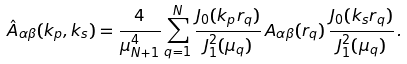<formula> <loc_0><loc_0><loc_500><loc_500>\hat { A } _ { \alpha \beta } ( k _ { p } , k _ { s } ) = \frac { 4 } { \mu _ { N + 1 } ^ { 4 } } \sum _ { q = 1 } ^ { N } \frac { J _ { 0 } ( k _ { p } r _ { q } ) } { J _ { 1 } ^ { 2 } ( \mu _ { q } ) } \, A _ { \alpha \beta } ( r _ { q } ) \, \frac { J _ { 0 } ( k _ { s } r _ { q } ) } { J _ { 1 } ^ { 2 } ( \mu _ { q } ) } \, .</formula> 